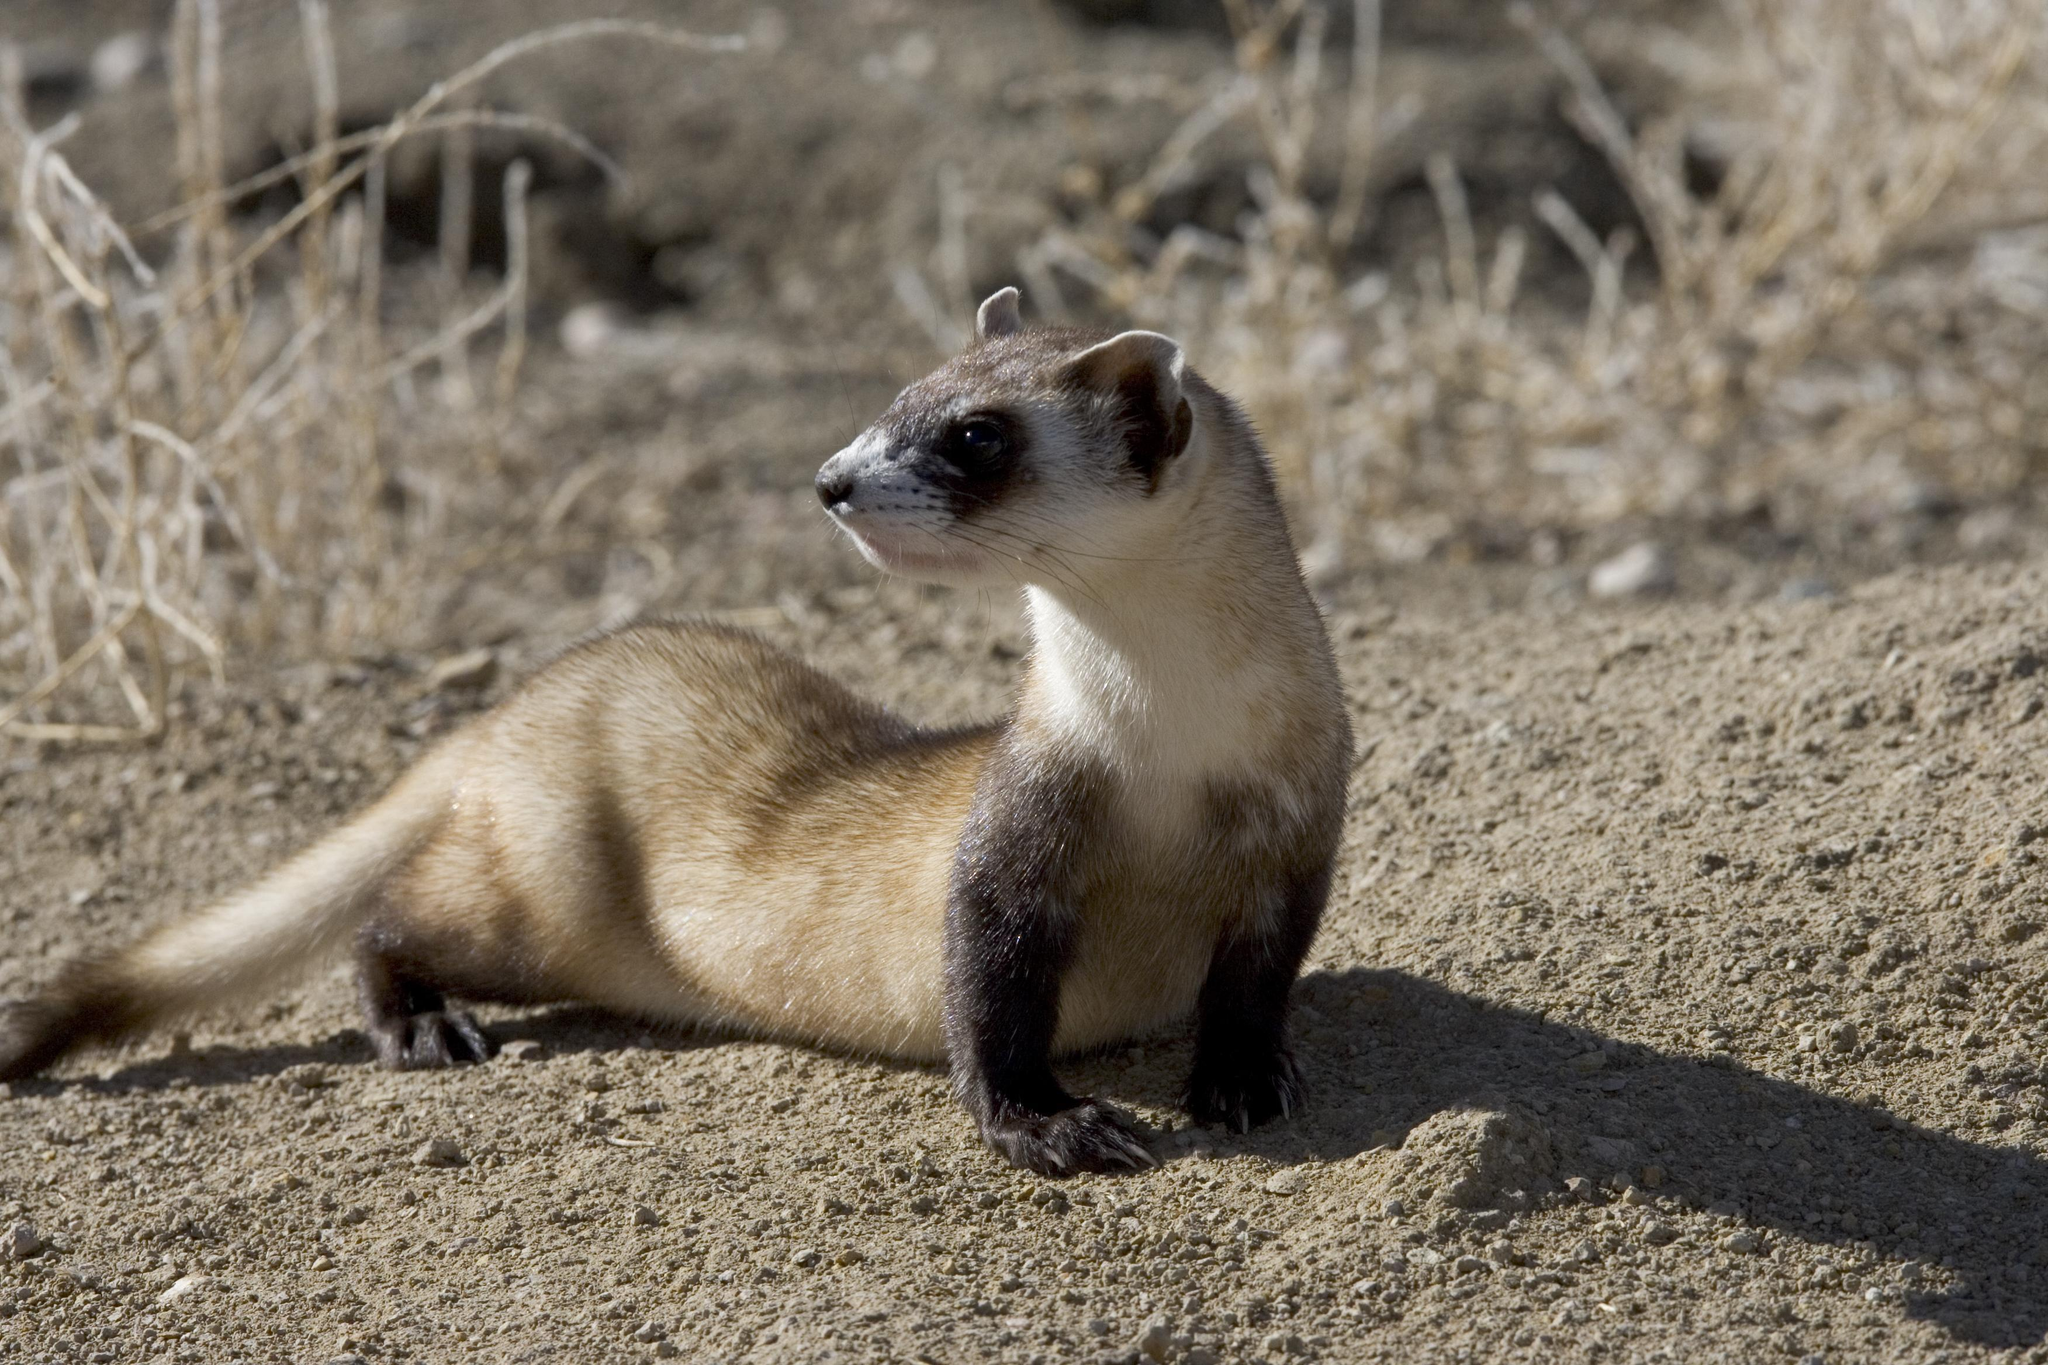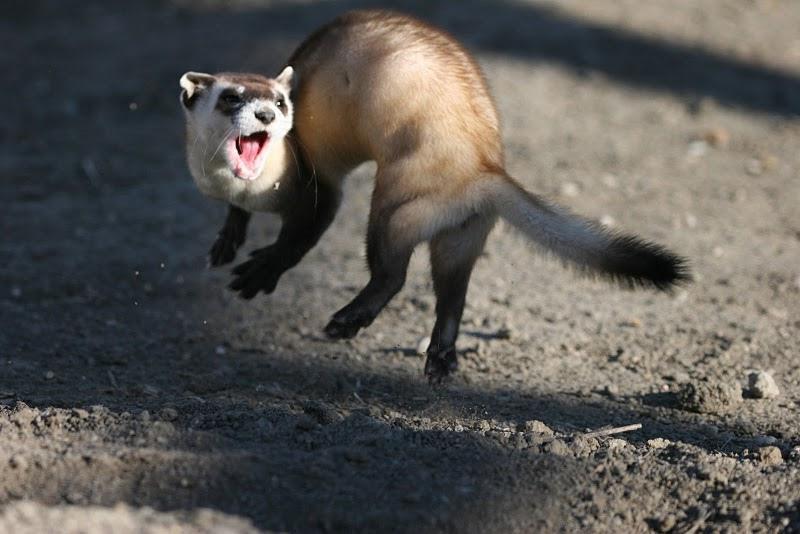The first image is the image on the left, the second image is the image on the right. Analyze the images presented: Is the assertion "In one of the photos, the animal has its mouth wide open." valid? Answer yes or no. Yes. The first image is the image on the left, the second image is the image on the right. Analyze the images presented: Is the assertion "in one image there is a lone black footed ferret looking out from a hole in the ground." valid? Answer yes or no. No. 